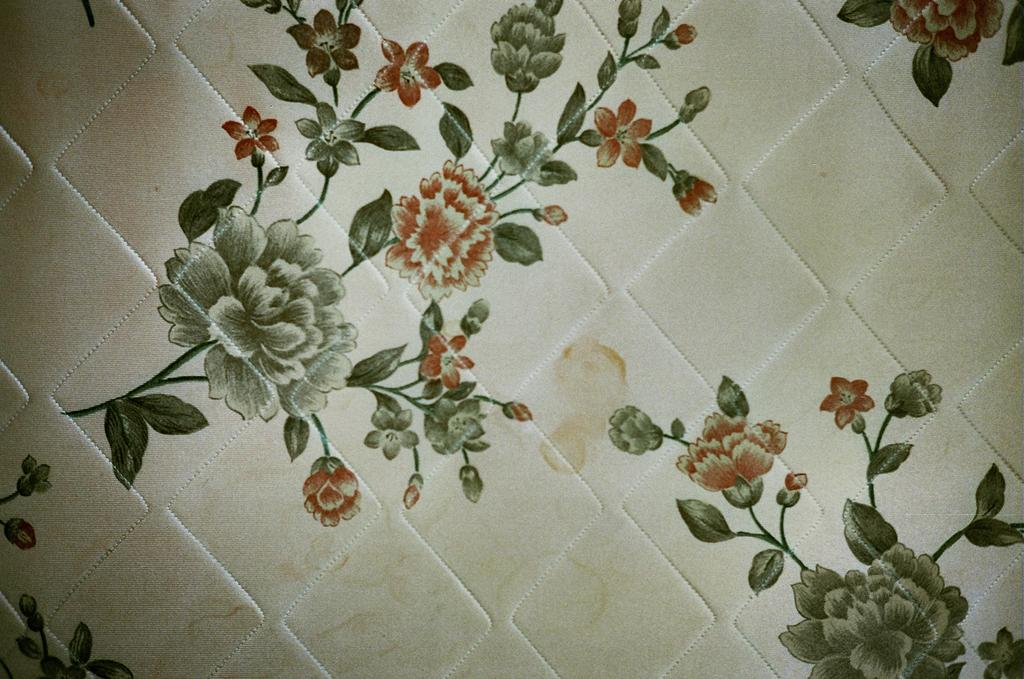What is present on the floor in the image? There is a bed mat in the image. What can be seen in the painting that is hanging on the wall? There are flowers and plants in the painting. What appliance can be seen in the painting? There is no appliance present in the painting; it features flowers and plants. What is the taste of the flowers in the painting? The painting is a visual representation, and therefore, it does not have a taste. 